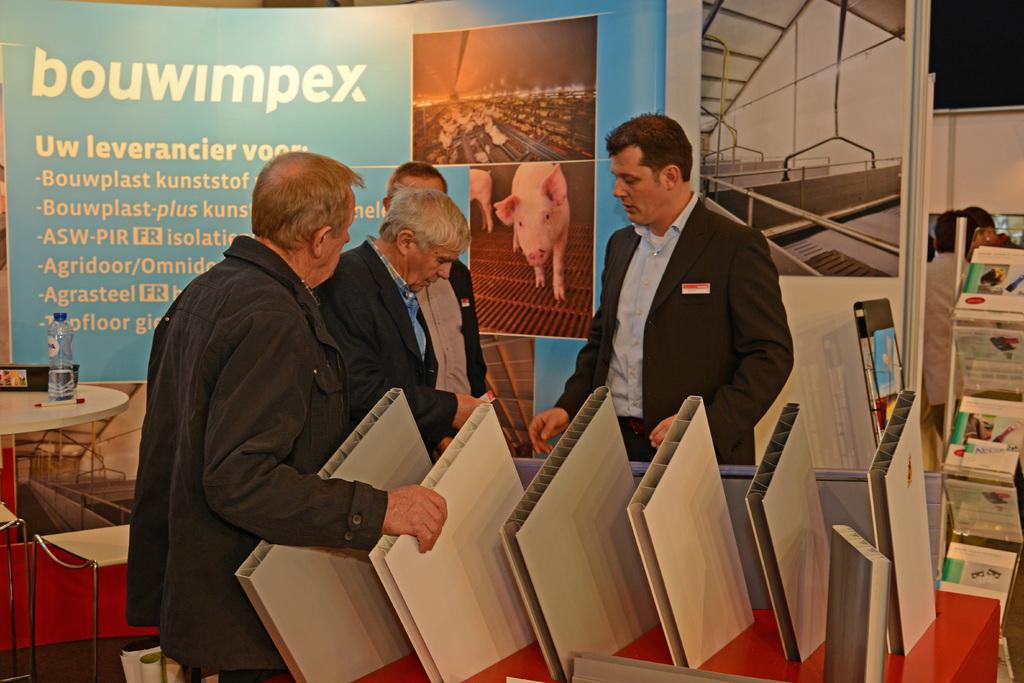How many people are present in the image? There are four persons standing in the image. What can be seen on the tables in the image? There are objects on the tables in the image. What is visible in the background of the image? There are boards and other items visible in the background of the image. What type of stone is being used for thought in the image? There is no stone or thought process depicted in the image. What type of food is being served on the tables in the image? The facts do not specify what type of objects are on the tables, so we cannot determine if they are food items. 